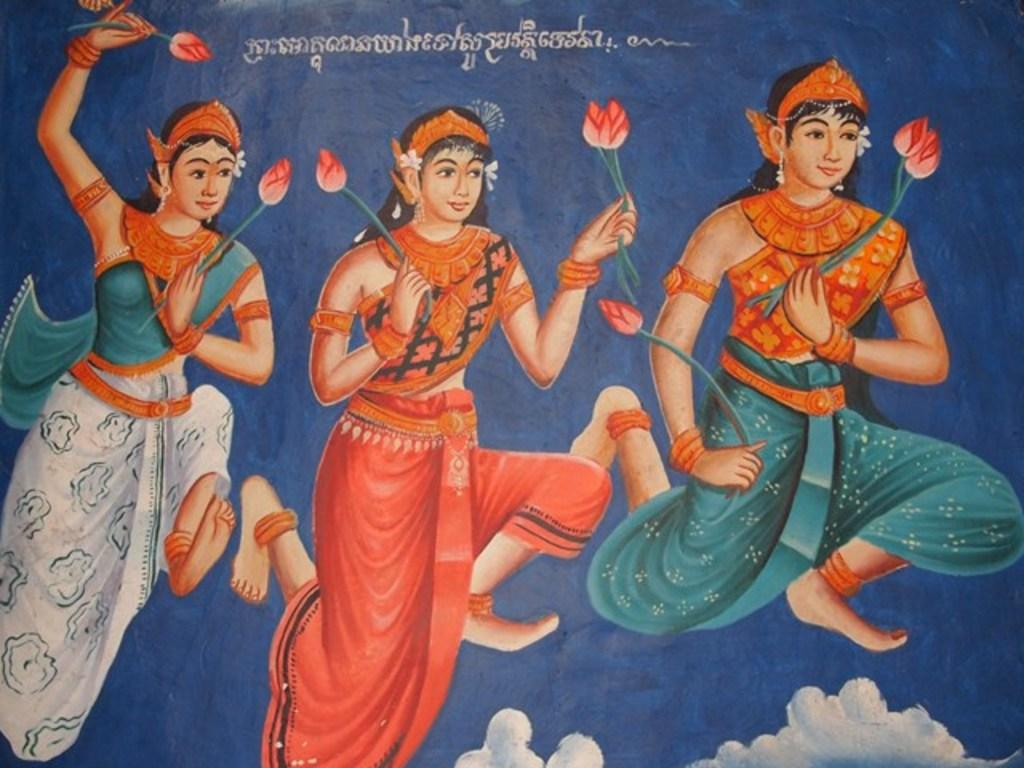What type of artwork can be seen in the image? There are paintings in the image. What type of degree is required to understand the worm in the painting? There is no worm or painting with a worm present in the image, so the question is not applicable. 